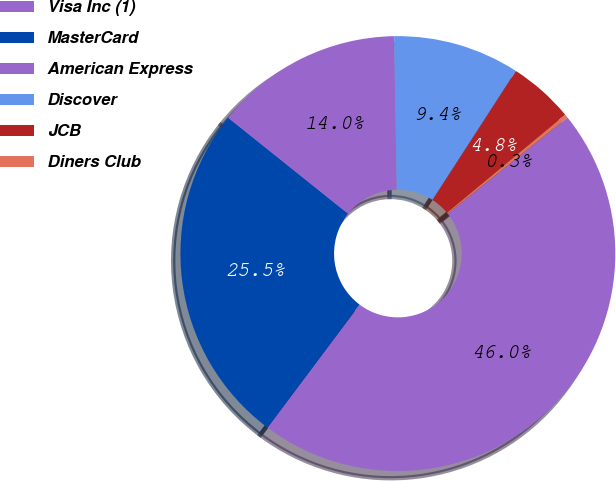Convert chart to OTSL. <chart><loc_0><loc_0><loc_500><loc_500><pie_chart><fcel>Visa Inc (1)<fcel>MasterCard<fcel>American Express<fcel>Discover<fcel>JCB<fcel>Diners Club<nl><fcel>45.98%<fcel>25.51%<fcel>13.98%<fcel>9.41%<fcel>4.84%<fcel>0.27%<nl></chart> 